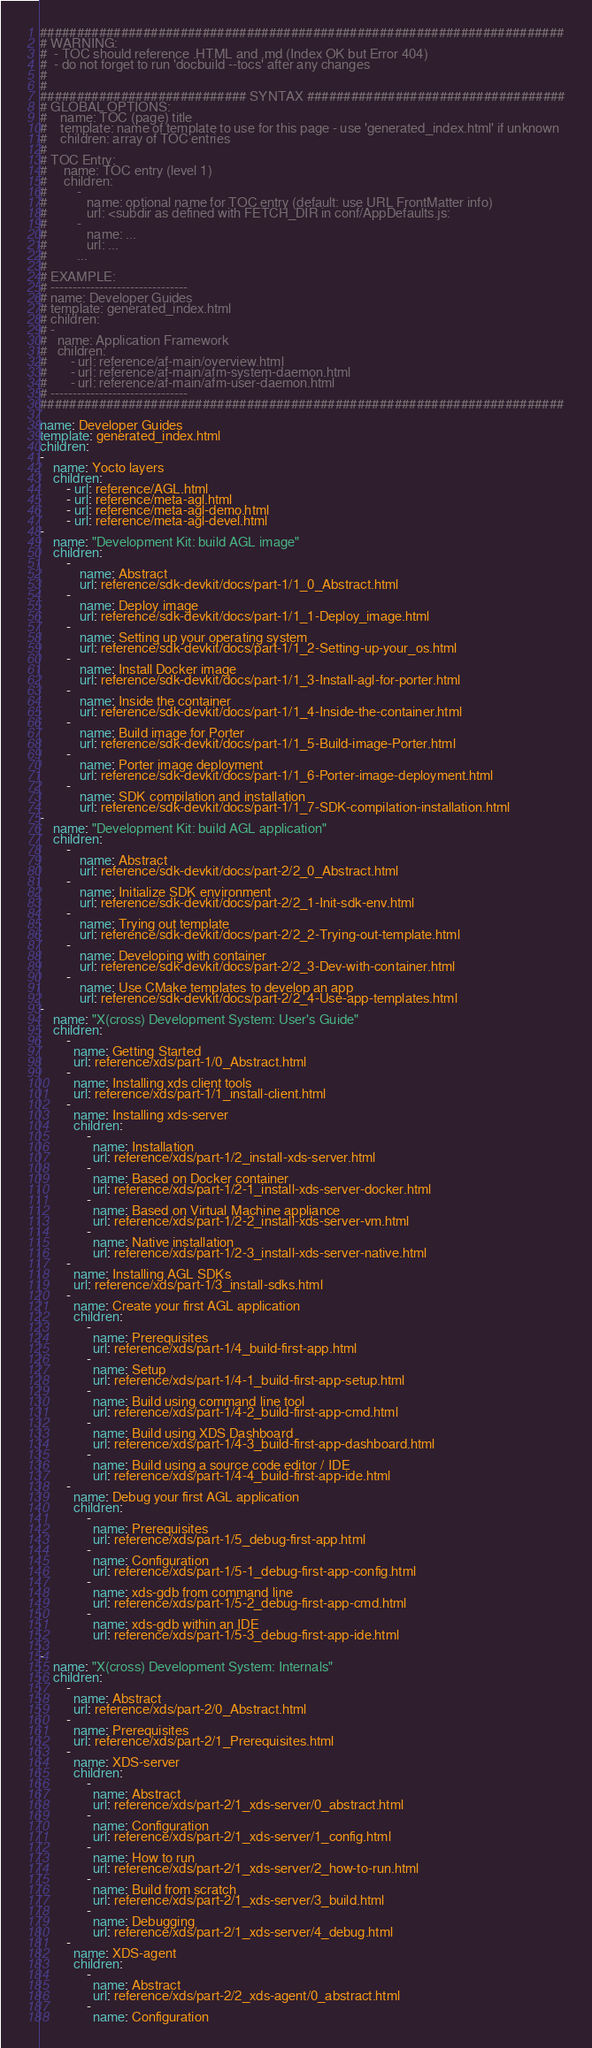<code> <loc_0><loc_0><loc_500><loc_500><_YAML_>#######################################################################
# WARNING:
#  - TOC should reference .HTML and .md (Index OK but Error 404)
#  - do not forget to run 'docbuild --tocs' after any changes
#
#
############################ SYNTAX ###################################
# GLOBAL OPTIONS:
#    name: TOC (page) title
#    template: name of template to use for this page - use 'generated_index.html' if unknown
#    children: array of TOC entries
#
# TOC Entry:
#     name: TOC entry (level 1)
#     children:
#         -
#            name: optional name for TOC entry (default: use URL FrontMatter info)
#            url: <subdir as defined with FETCH_DIR in conf/AppDefaults.js:
#         -
#            name: ...
#            url: ...
#         ...
#
# EXAMPLE:
# -------------------------------
# name: Developer Guides
# template: generated_index.html
# children:
# -
#   name: Application Framework
#   children:
#       - url: reference/af-main/overview.html
#       - url: reference/af-main/afm-system-daemon.html
#       - url: reference/af-main/afm-user-daemon.html
# -------------------------------
#######################################################################

name: Developer Guides
template: generated_index.html
children:
-
    name: Yocto layers
    children:
        - url: reference/AGL.html
        - url: reference/meta-agl.html
        - url: reference/meta-agl-demo.html
        - url: reference/meta-agl-devel.html
-
    name: "Development Kit: build AGL image"
    children:
        -
            name: Abstract
            url: reference/sdk-devkit/docs/part-1/1_0_Abstract.html
        -
            name: Deploy image
            url: reference/sdk-devkit/docs/part-1/1_1-Deploy_image.html
        -
            name: Setting up your operating system
            url: reference/sdk-devkit/docs/part-1/1_2-Setting-up-your_os.html
        -
            name: Install Docker image
            url: reference/sdk-devkit/docs/part-1/1_3-Install-agl-for-porter.html
        -
            name: Inside the container
            url: reference/sdk-devkit/docs/part-1/1_4-Inside-the-container.html
        -
            name: Build image for Porter
            url: reference/sdk-devkit/docs/part-1/1_5-Build-image-Porter.html
        -
            name: Porter image deployment
            url: reference/sdk-devkit/docs/part-1/1_6-Porter-image-deployment.html
        -
            name: SDK compilation and installation
            url: reference/sdk-devkit/docs/part-1/1_7-SDK-compilation-installation.html
-
    name: "Development Kit: build AGL application"
    children:
        -
            name: Abstract
            url: reference/sdk-devkit/docs/part-2/2_0_Abstract.html
        -
            name: Initialize SDK environment
            url: reference/sdk-devkit/docs/part-2/2_1-Init-sdk-env.html
        -
            name: Trying out template
            url: reference/sdk-devkit/docs/part-2/2_2-Trying-out-template.html
        -
            name: Developing with container
            url: reference/sdk-devkit/docs/part-2/2_3-Dev-with-container.html
        -
            name: Use CMake templates to develop an app
            url: reference/sdk-devkit/docs/part-2/2_4-Use-app-templates.html
-
    name: "X(cross) Development System: User's Guide"
    children:
        -
          name: Getting Started
          url: reference/xds/part-1/0_Abstract.html
        -
          name: Installing xds client tools
          url: reference/xds/part-1/1_install-client.html
        -
          name: Installing xds-server
          children:
              -
                name: Installation
                url: reference/xds/part-1/2_install-xds-server.html
              -
                name: Based on Docker container
                url: reference/xds/part-1/2-1_install-xds-server-docker.html
              -
                name: Based on Virtual Machine appliance
                url: reference/xds/part-1/2-2_install-xds-server-vm.html
              -
                name: Native installation
                url: reference/xds/part-1/2-3_install-xds-server-native.html
        -
          name: Installing AGL SDKs
          url: reference/xds/part-1/3_install-sdks.html
        -
          name: Create your first AGL application
          children:
              -
                name: Prerequisites
                url: reference/xds/part-1/4_build-first-app.html
              -
                name: Setup
                url: reference/xds/part-1/4-1_build-first-app-setup.html
              -
                name: Build using command line tool
                url: reference/xds/part-1/4-2_build-first-app-cmd.html
              -
                name: Build using XDS Dashboard
                url: reference/xds/part-1/4-3_build-first-app-dashboard.html
              -
                name: Build using a source code editor / IDE
                url: reference/xds/part-1/4-4_build-first-app-ide.html
        -
          name: Debug your first AGL application
          children:
              -
                name: Prerequisites
                url: reference/xds/part-1/5_debug-first-app.html
              -
                name: Configuration
                url: reference/xds/part-1/5-1_debug-first-app-config.html
              -
                name: xds-gdb from command line
                url: reference/xds/part-1/5-2_debug-first-app-cmd.html
              -
                name: xds-gdb within an IDE
                url: reference/xds/part-1/5-3_debug-first-app-ide.html

-
    name: "X(cross) Development System: Internals"
    children:
        -
          name: Abstract
          url: reference/xds/part-2/0_Abstract.html
        -
          name: Prerequisites
          url: reference/xds/part-2/1_Prerequisites.html
        -
          name: XDS-server
          children:
              -
                name: Abstract
                url: reference/xds/part-2/1_xds-server/0_abstract.html
              -
                name: Configuration
                url: reference/xds/part-2/1_xds-server/1_config.html
              -
                name: How to run
                url: reference/xds/part-2/1_xds-server/2_how-to-run.html
              -
                name: Build from scratch
                url: reference/xds/part-2/1_xds-server/3_build.html
              -
                name: Debugging
                url: reference/xds/part-2/1_xds-server/4_debug.html
        -
          name: XDS-agent
          children:
              -
                name: Abstract
                url: reference/xds/part-2/2_xds-agent/0_abstract.html
              -
                name: Configuration</code> 